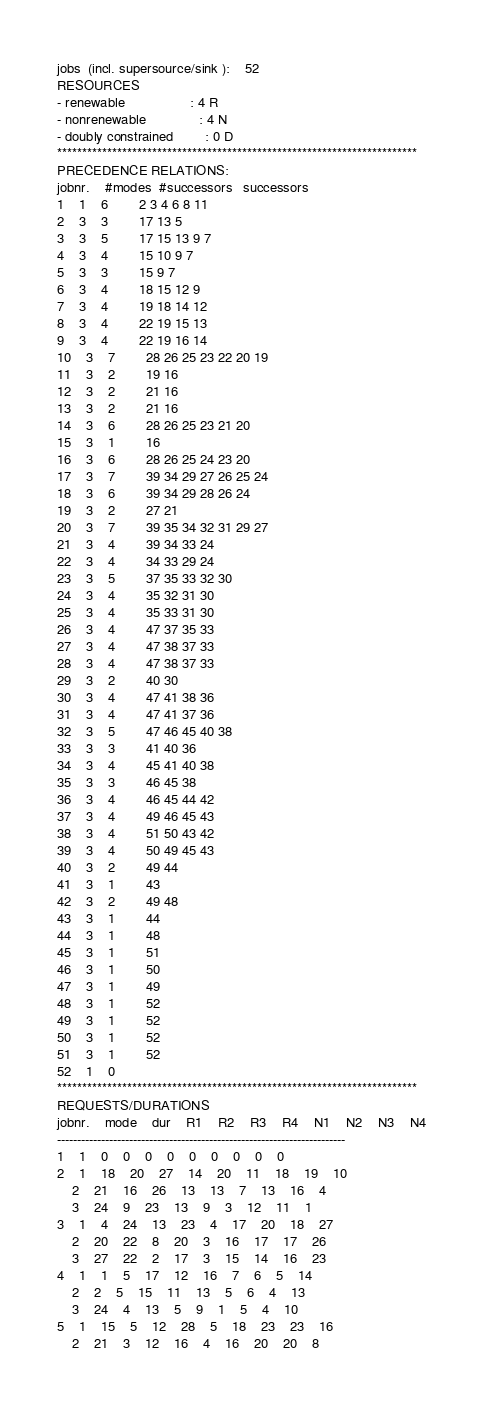<code> <loc_0><loc_0><loc_500><loc_500><_ObjectiveC_>jobs  (incl. supersource/sink ):	52
RESOURCES
- renewable                 : 4 R
- nonrenewable              : 4 N
- doubly constrained        : 0 D
************************************************************************
PRECEDENCE RELATIONS:
jobnr.    #modes  #successors   successors
1	1	6		2 3 4 6 8 11 
2	3	3		17 13 5 
3	3	5		17 15 13 9 7 
4	3	4		15 10 9 7 
5	3	3		15 9 7 
6	3	4		18 15 12 9 
7	3	4		19 18 14 12 
8	3	4		22 19 15 13 
9	3	4		22 19 16 14 
10	3	7		28 26 25 23 22 20 19 
11	3	2		19 16 
12	3	2		21 16 
13	3	2		21 16 
14	3	6		28 26 25 23 21 20 
15	3	1		16 
16	3	6		28 26 25 24 23 20 
17	3	7		39 34 29 27 26 25 24 
18	3	6		39 34 29 28 26 24 
19	3	2		27 21 
20	3	7		39 35 34 32 31 29 27 
21	3	4		39 34 33 24 
22	3	4		34 33 29 24 
23	3	5		37 35 33 32 30 
24	3	4		35 32 31 30 
25	3	4		35 33 31 30 
26	3	4		47 37 35 33 
27	3	4		47 38 37 33 
28	3	4		47 38 37 33 
29	3	2		40 30 
30	3	4		47 41 38 36 
31	3	4		47 41 37 36 
32	3	5		47 46 45 40 38 
33	3	3		41 40 36 
34	3	4		45 41 40 38 
35	3	3		46 45 38 
36	3	4		46 45 44 42 
37	3	4		49 46 45 43 
38	3	4		51 50 43 42 
39	3	4		50 49 45 43 
40	3	2		49 44 
41	3	1		43 
42	3	2		49 48 
43	3	1		44 
44	3	1		48 
45	3	1		51 
46	3	1		50 
47	3	1		49 
48	3	1		52 
49	3	1		52 
50	3	1		52 
51	3	1		52 
52	1	0		
************************************************************************
REQUESTS/DURATIONS
jobnr.	mode	dur	R1	R2	R3	R4	N1	N2	N3	N4	
------------------------------------------------------------------------
1	1	0	0	0	0	0	0	0	0	0	
2	1	18	20	27	14	20	11	18	19	10	
	2	21	16	26	13	13	7	13	16	4	
	3	24	9	23	13	9	3	12	11	1	
3	1	4	24	13	23	4	17	20	18	27	
	2	20	22	8	20	3	16	17	17	26	
	3	27	22	2	17	3	15	14	16	23	
4	1	1	5	17	12	16	7	6	5	14	
	2	2	5	15	11	13	5	6	4	13	
	3	24	4	13	5	9	1	5	4	10	
5	1	15	5	12	28	5	18	23	23	16	
	2	21	3	12	16	4	16	20	20	8	</code> 